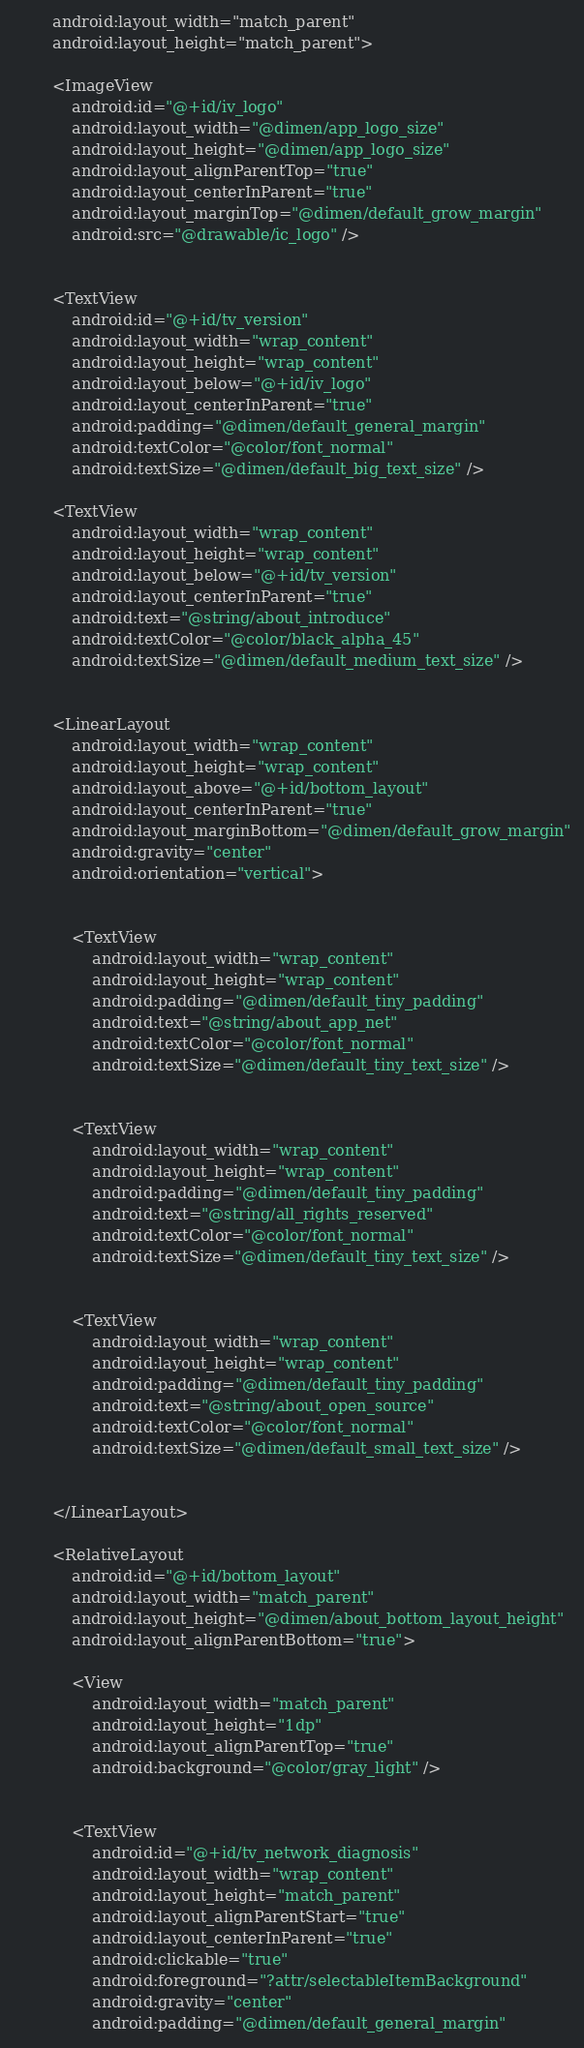<code> <loc_0><loc_0><loc_500><loc_500><_XML_>        android:layout_width="match_parent"
        android:layout_height="match_parent">

        <ImageView
            android:id="@+id/iv_logo"
            android:layout_width="@dimen/app_logo_size"
            android:layout_height="@dimen/app_logo_size"
            android:layout_alignParentTop="true"
            android:layout_centerInParent="true"
            android:layout_marginTop="@dimen/default_grow_margin"
            android:src="@drawable/ic_logo" />


        <TextView
            android:id="@+id/tv_version"
            android:layout_width="wrap_content"
            android:layout_height="wrap_content"
            android:layout_below="@+id/iv_logo"
            android:layout_centerInParent="true"
            android:padding="@dimen/default_general_margin"
            android:textColor="@color/font_normal"
            android:textSize="@dimen/default_big_text_size" />

        <TextView
            android:layout_width="wrap_content"
            android:layout_height="wrap_content"
            android:layout_below="@+id/tv_version"
            android:layout_centerInParent="true"
            android:text="@string/about_introduce"
            android:textColor="@color/black_alpha_45"
            android:textSize="@dimen/default_medium_text_size" />


        <LinearLayout
            android:layout_width="wrap_content"
            android:layout_height="wrap_content"
            android:layout_above="@+id/bottom_layout"
            android:layout_centerInParent="true"
            android:layout_marginBottom="@dimen/default_grow_margin"
            android:gravity="center"
            android:orientation="vertical">


            <TextView
                android:layout_width="wrap_content"
                android:layout_height="wrap_content"
                android:padding="@dimen/default_tiny_padding"
                android:text="@string/about_app_net"
                android:textColor="@color/font_normal"
                android:textSize="@dimen/default_tiny_text_size" />


            <TextView
                android:layout_width="wrap_content"
                android:layout_height="wrap_content"
                android:padding="@dimen/default_tiny_padding"
                android:text="@string/all_rights_reserved"
                android:textColor="@color/font_normal"
                android:textSize="@dimen/default_tiny_text_size" />


            <TextView
                android:layout_width="wrap_content"
                android:layout_height="wrap_content"
                android:padding="@dimen/default_tiny_padding"
                android:text="@string/about_open_source"
                android:textColor="@color/font_normal"
                android:textSize="@dimen/default_small_text_size" />


        </LinearLayout>

        <RelativeLayout
            android:id="@+id/bottom_layout"
            android:layout_width="match_parent"
            android:layout_height="@dimen/about_bottom_layout_height"
            android:layout_alignParentBottom="true">

            <View
                android:layout_width="match_parent"
                android:layout_height="1dp"
                android:layout_alignParentTop="true"
                android:background="@color/gray_light" />


            <TextView
                android:id="@+id/tv_network_diagnosis"
                android:layout_width="wrap_content"
                android:layout_height="match_parent"
                android:layout_alignParentStart="true"
                android:layout_centerInParent="true"
                android:clickable="true"
                android:foreground="?attr/selectableItemBackground"
                android:gravity="center"
                android:padding="@dimen/default_general_margin"</code> 